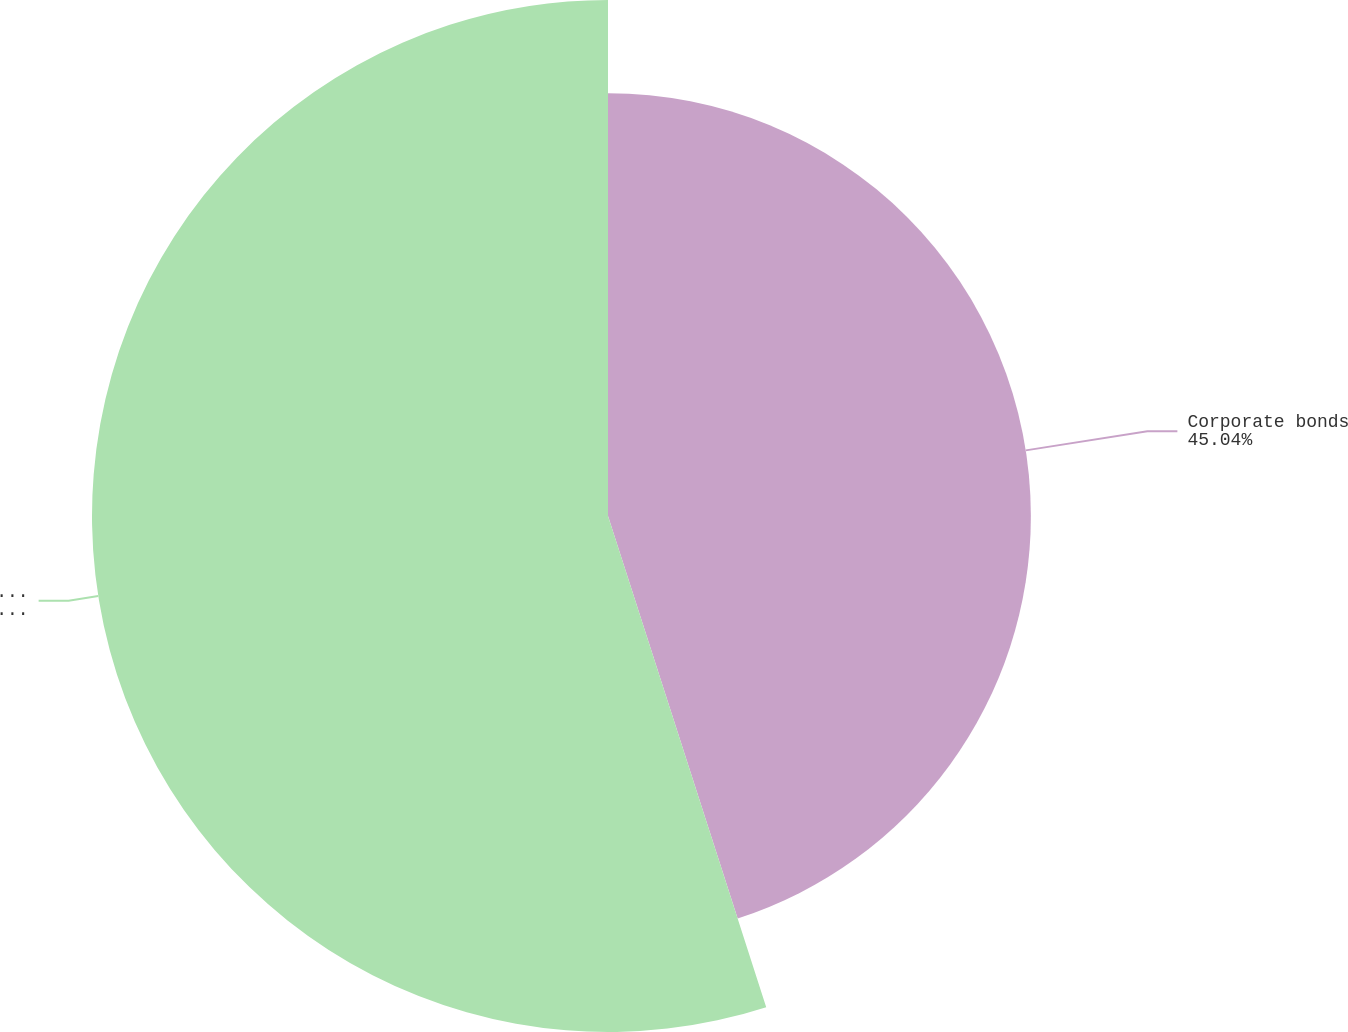<chart> <loc_0><loc_0><loc_500><loc_500><pie_chart><fcel>Corporate bonds<fcel>Total securities<nl><fcel>45.04%<fcel>54.96%<nl></chart> 